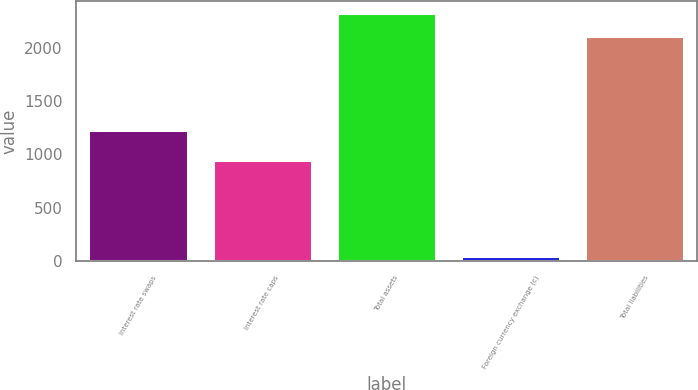Convert chart. <chart><loc_0><loc_0><loc_500><loc_500><bar_chart><fcel>Interest rate swaps<fcel>Interest rate caps<fcel>Total assets<fcel>Foreign currency exchange (c)<fcel>Total liabilities<nl><fcel>1227<fcel>946<fcel>2320.4<fcel>49<fcel>2108<nl></chart> 